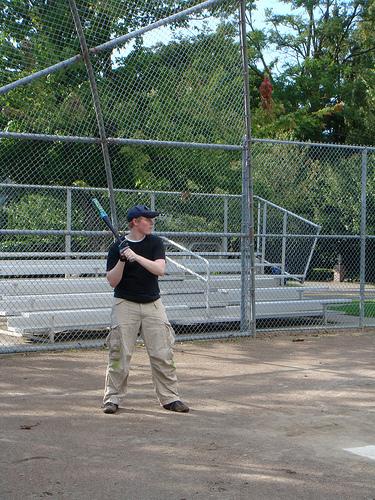Is this a batting cage?
Quick response, please. No. What is the fence made of?
Keep it brief. Metal. What sport is this?
Give a very brief answer. Baseball. How many rows of benches are there?
Quick response, please. 4. What kind of trees are in the background?
Keep it brief. Elm. What kind of pants is the person wearing?
Give a very brief answer. Cargo. What is the man holding?
Keep it brief. Baseball bat. Who is the behind the boy with the bat?
Answer briefly. No one. 